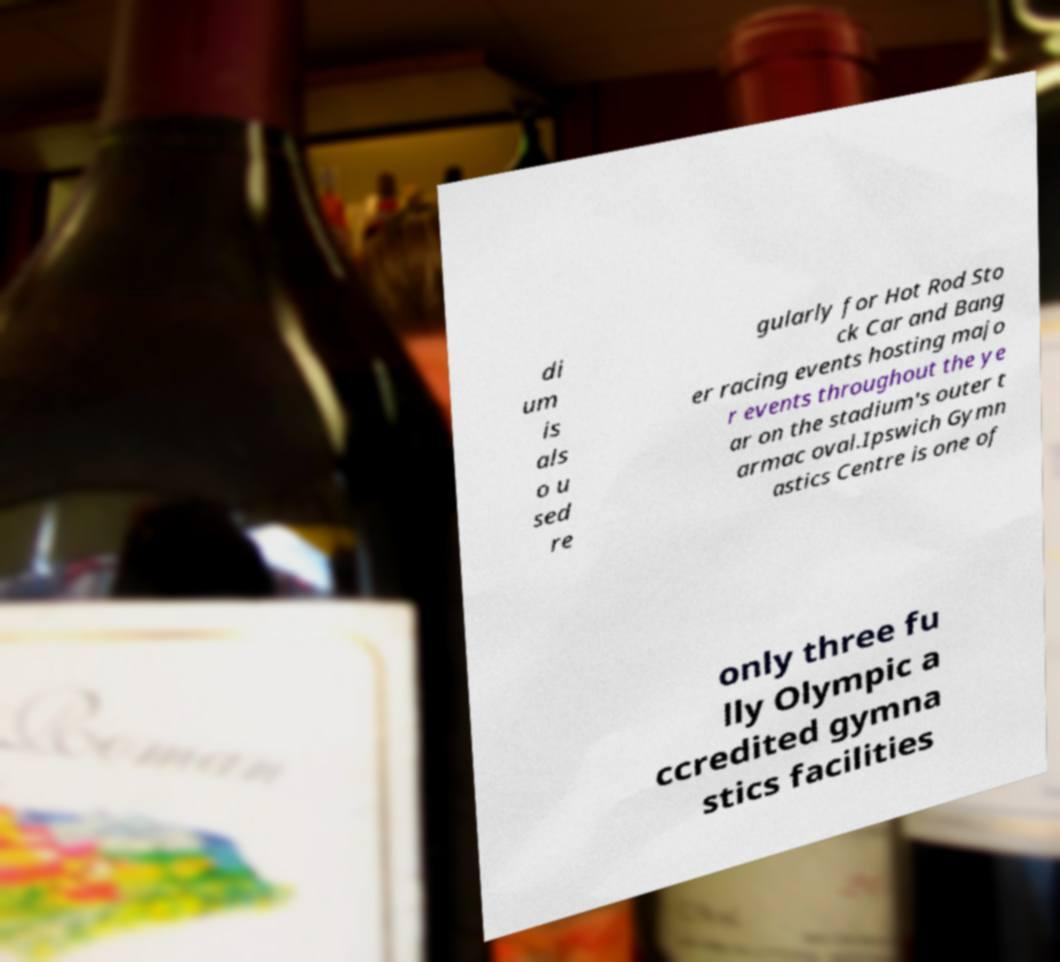For documentation purposes, I need the text within this image transcribed. Could you provide that? di um is als o u sed re gularly for Hot Rod Sto ck Car and Bang er racing events hosting majo r events throughout the ye ar on the stadium's outer t armac oval.Ipswich Gymn astics Centre is one of only three fu lly Olympic a ccredited gymna stics facilities 